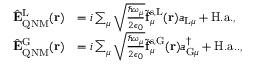Convert formula to latex. <formula><loc_0><loc_0><loc_500><loc_500>\begin{array} { r l } { \hat { E } _ { Q N M } ^ { L } ( r ) } & { = i \sum _ { \mu } \sqrt { \frac { \hbar { \omega } _ { \mu } } { 2 \epsilon _ { 0 } } } \tilde { f } _ { \mu } ^ { s , L } ( r ) a _ { L \mu } + H . a . , } \\ { \hat { E } _ { Q N M } ^ { G } ( r ) } & { = i \sum _ { \mu } \sqrt { \frac { \hbar { \omega } _ { \mu } } { 2 \epsilon _ { 0 } } } \tilde { f } _ { \mu } ^ { s , G } ( r ) a _ { G \mu } ^ { \dagger } + H . a . . , } \end{array}</formula> 